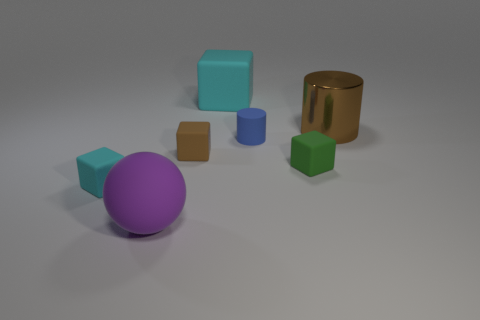Subtract 1 cubes. How many cubes are left? 3 Add 1 small rubber cubes. How many objects exist? 8 Subtract all cylinders. How many objects are left? 5 Subtract all purple cylinders. Subtract all purple matte spheres. How many objects are left? 6 Add 3 big rubber spheres. How many big rubber spheres are left? 4 Add 4 big objects. How many big objects exist? 7 Subtract 0 gray cylinders. How many objects are left? 7 